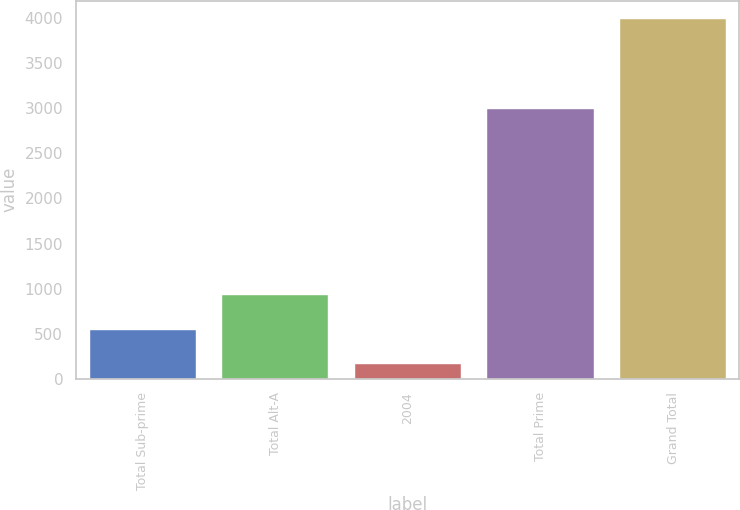Convert chart to OTSL. <chart><loc_0><loc_0><loc_500><loc_500><bar_chart><fcel>Total Sub-prime<fcel>Total Alt-A<fcel>2004<fcel>Total Prime<fcel>Grand Total<nl><fcel>546<fcel>929<fcel>163<fcel>2996<fcel>3993<nl></chart> 